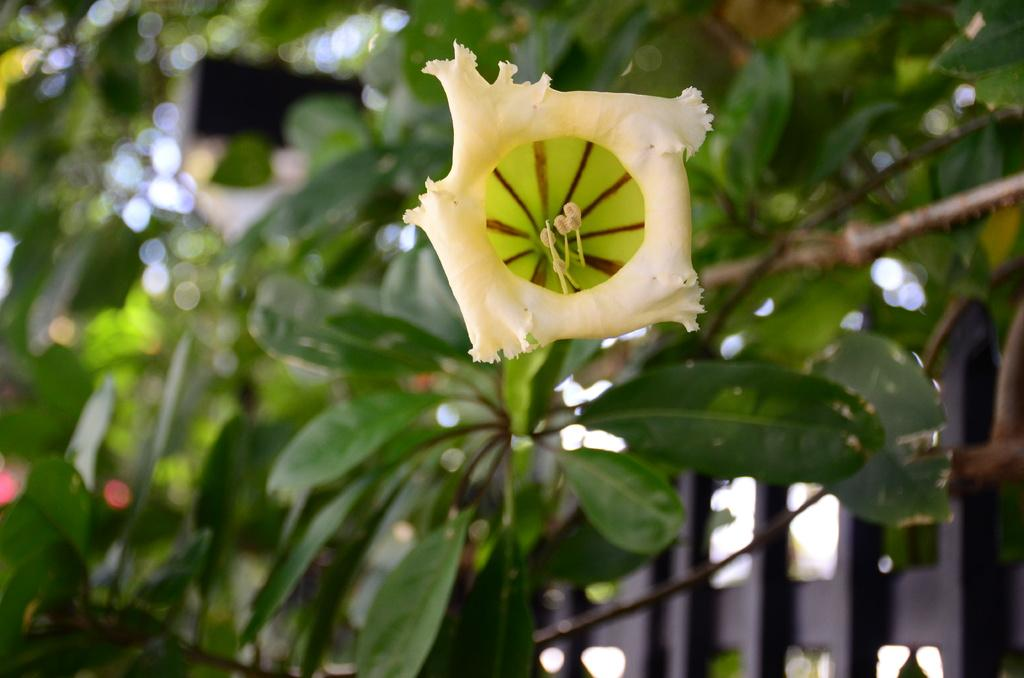What is the main subject of the image? There is a flower in the image. Can you describe the colors of the flower? The flower has white and green colors. Are there any unopened parts of the flower visible? Yes, there are flower buds in the image. What can be seen in the background of the image? There are trees in the background of the image. What other objects are present in the image? There are black color poles in the image. What type of cap is the flower wearing in the image? There is no cap present on the flower in the image. Is there a hammer visible in the image? No, there is no hammer present in the image. 